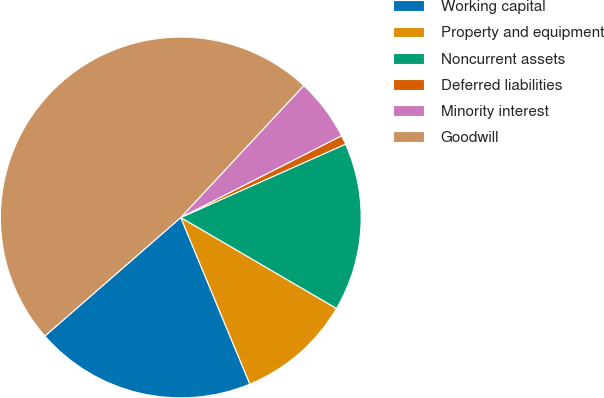Convert chart to OTSL. <chart><loc_0><loc_0><loc_500><loc_500><pie_chart><fcel>Working capital<fcel>Property and equipment<fcel>Noncurrent assets<fcel>Deferred liabilities<fcel>Minority interest<fcel>Goodwill<nl><fcel>19.84%<fcel>10.33%<fcel>15.08%<fcel>0.82%<fcel>5.57%<fcel>48.36%<nl></chart> 